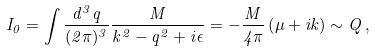Convert formula to latex. <formula><loc_0><loc_0><loc_500><loc_500>I _ { 0 } = \int \frac { d ^ { 3 } q } { ( 2 \pi ) ^ { 3 } } \frac { M } { k ^ { 2 } - q ^ { 2 } + i \epsilon } = - \frac { M } { 4 \pi } \left ( \mu + i k \right ) \sim Q \, ,</formula> 